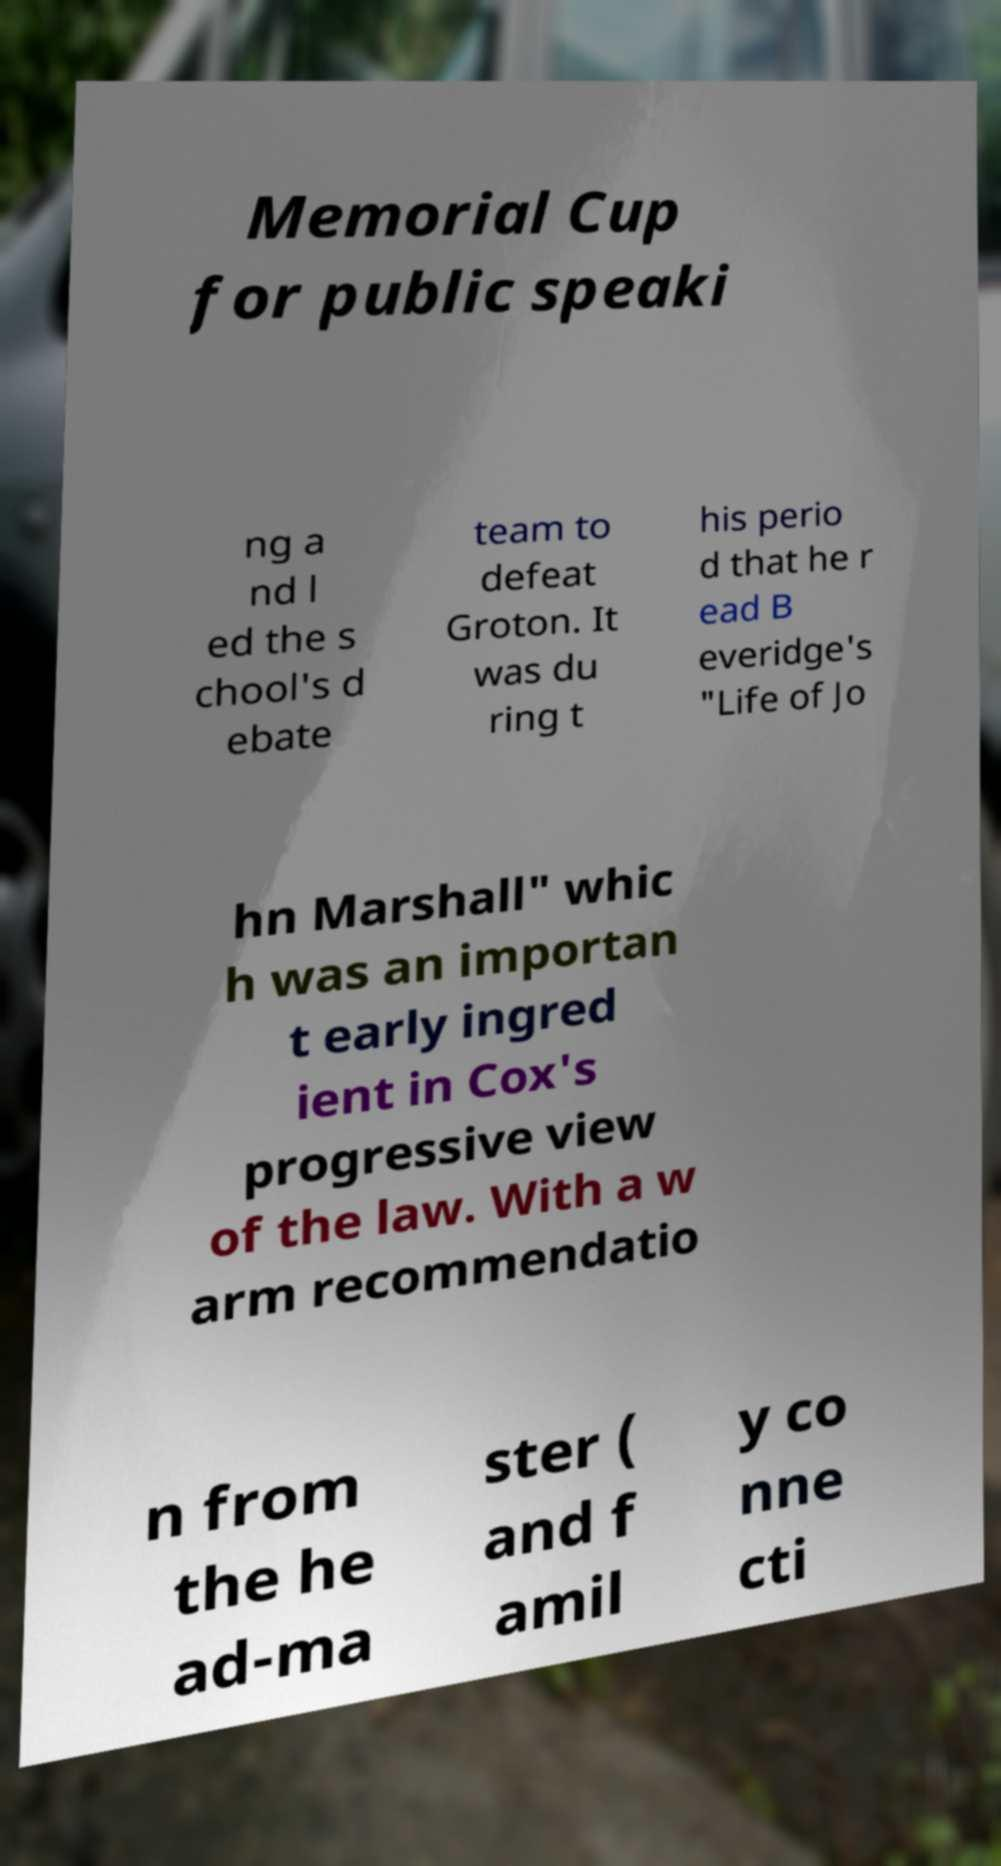There's text embedded in this image that I need extracted. Can you transcribe it verbatim? Memorial Cup for public speaki ng a nd l ed the s chool's d ebate team to defeat Groton. It was du ring t his perio d that he r ead B everidge's "Life of Jo hn Marshall" whic h was an importan t early ingred ient in Cox's progressive view of the law. With a w arm recommendatio n from the he ad-ma ster ( and f amil y co nne cti 